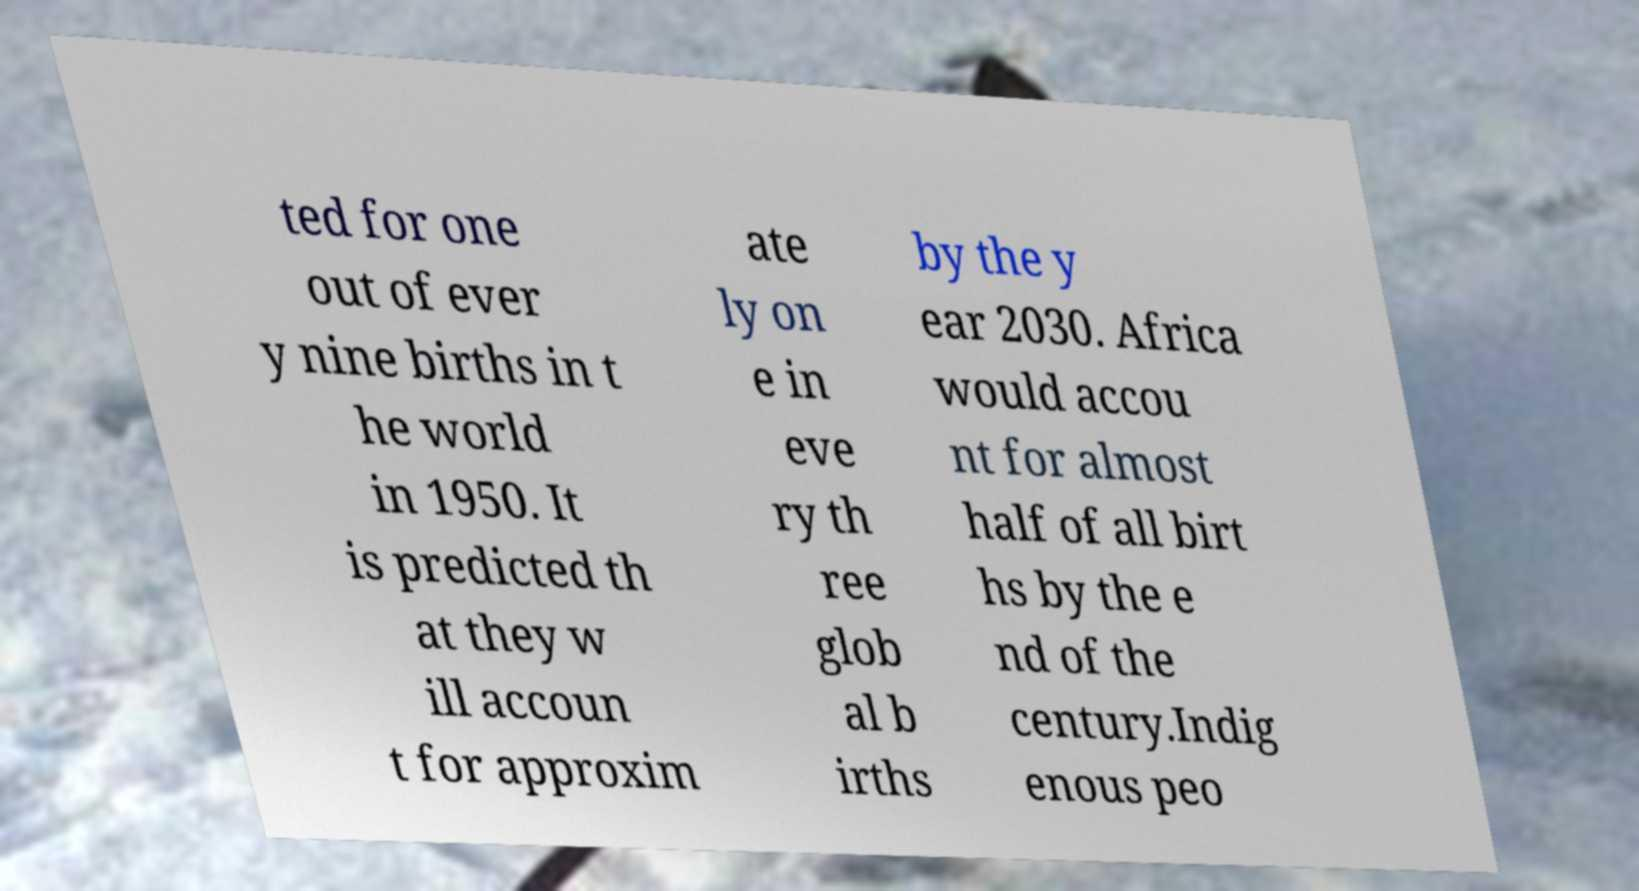Please identify and transcribe the text found in this image. ted for one out of ever y nine births in t he world in 1950. It is predicted th at they w ill accoun t for approxim ate ly on e in eve ry th ree glob al b irths by the y ear 2030. Africa would accou nt for almost half of all birt hs by the e nd of the century.Indig enous peo 